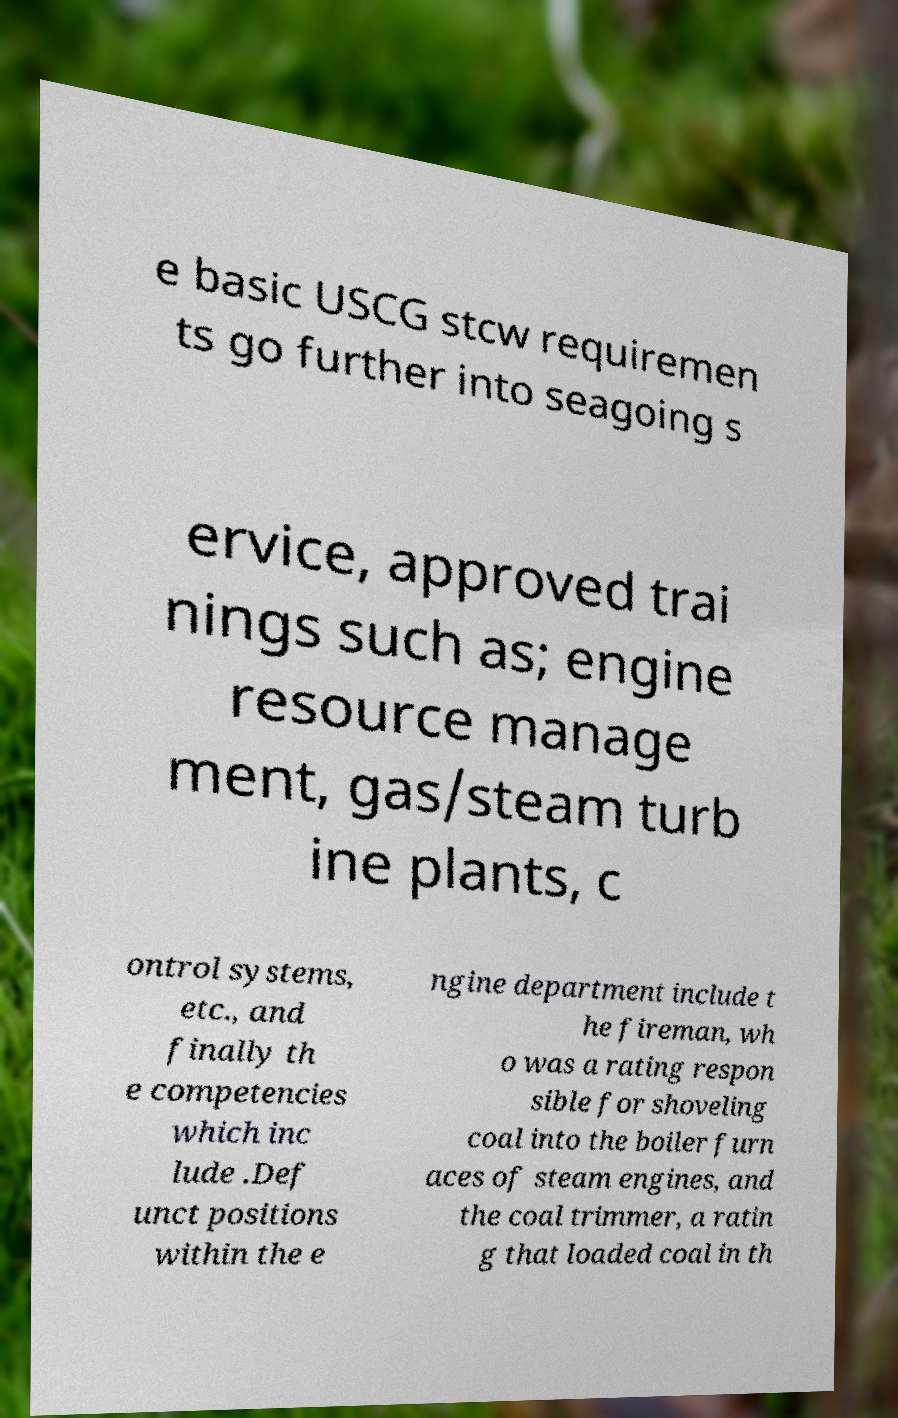What messages or text are displayed in this image? I need them in a readable, typed format. e basic USCG stcw requiremen ts go further into seagoing s ervice, approved trai nings such as; engine resource manage ment, gas/steam turb ine plants, c ontrol systems, etc., and finally th e competencies which inc lude .Def unct positions within the e ngine department include t he fireman, wh o was a rating respon sible for shoveling coal into the boiler furn aces of steam engines, and the coal trimmer, a ratin g that loaded coal in th 